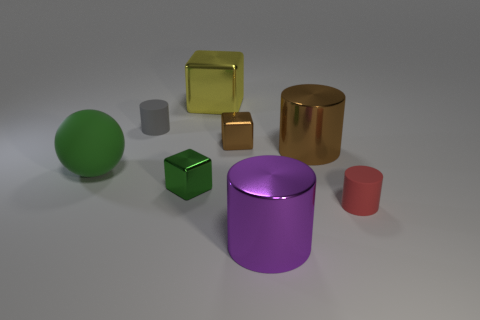What is the size of the metal cube that is the same color as the matte sphere?
Your answer should be compact. Small. Are there any large green matte objects that are to the left of the large object that is on the left side of the tiny matte cylinder behind the green shiny thing?
Ensure brevity in your answer.  No. What shape is the small metallic thing that is the same color as the large sphere?
Your answer should be very brief. Cube. Is there anything else that has the same material as the large purple thing?
Ensure brevity in your answer.  Yes. How many small things are cyan matte balls or shiny cylinders?
Provide a short and direct response. 0. There is a matte thing that is behind the big green matte thing; is it the same shape as the purple shiny object?
Keep it short and to the point. Yes. Are there fewer small purple metal spheres than small objects?
Your response must be concise. Yes. Is there any other thing of the same color as the rubber sphere?
Provide a succinct answer. Yes. The metal thing behind the gray rubber thing has what shape?
Your response must be concise. Cube. There is a big sphere; is its color the same as the tiny shiny block in front of the big rubber object?
Your answer should be compact. Yes. 